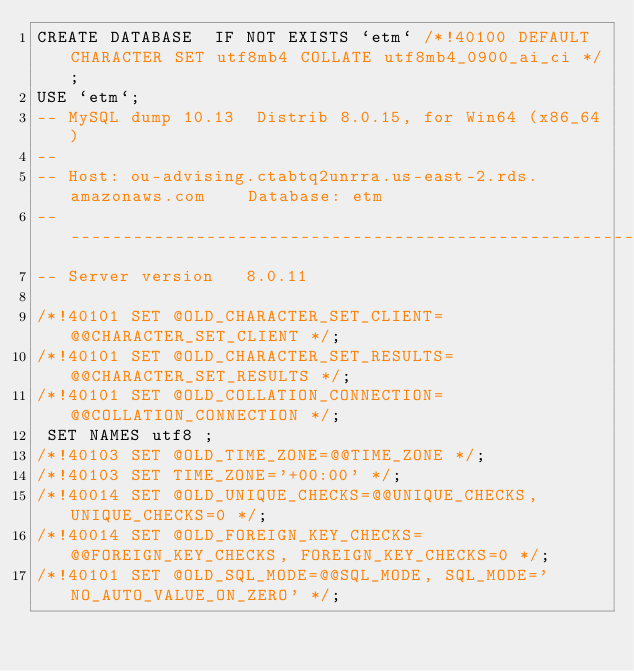<code> <loc_0><loc_0><loc_500><loc_500><_SQL_>CREATE DATABASE  IF NOT EXISTS `etm` /*!40100 DEFAULT CHARACTER SET utf8mb4 COLLATE utf8mb4_0900_ai_ci */;
USE `etm`;
-- MySQL dump 10.13  Distrib 8.0.15, for Win64 (x86_64)
--
-- Host: ou-advising.ctabtq2unrra.us-east-2.rds.amazonaws.com    Database: etm
-- ------------------------------------------------------
-- Server version	8.0.11

/*!40101 SET @OLD_CHARACTER_SET_CLIENT=@@CHARACTER_SET_CLIENT */;
/*!40101 SET @OLD_CHARACTER_SET_RESULTS=@@CHARACTER_SET_RESULTS */;
/*!40101 SET @OLD_COLLATION_CONNECTION=@@COLLATION_CONNECTION */;
 SET NAMES utf8 ;
/*!40103 SET @OLD_TIME_ZONE=@@TIME_ZONE */;
/*!40103 SET TIME_ZONE='+00:00' */;
/*!40014 SET @OLD_UNIQUE_CHECKS=@@UNIQUE_CHECKS, UNIQUE_CHECKS=0 */;
/*!40014 SET @OLD_FOREIGN_KEY_CHECKS=@@FOREIGN_KEY_CHECKS, FOREIGN_KEY_CHECKS=0 */;
/*!40101 SET @OLD_SQL_MODE=@@SQL_MODE, SQL_MODE='NO_AUTO_VALUE_ON_ZERO' */;</code> 